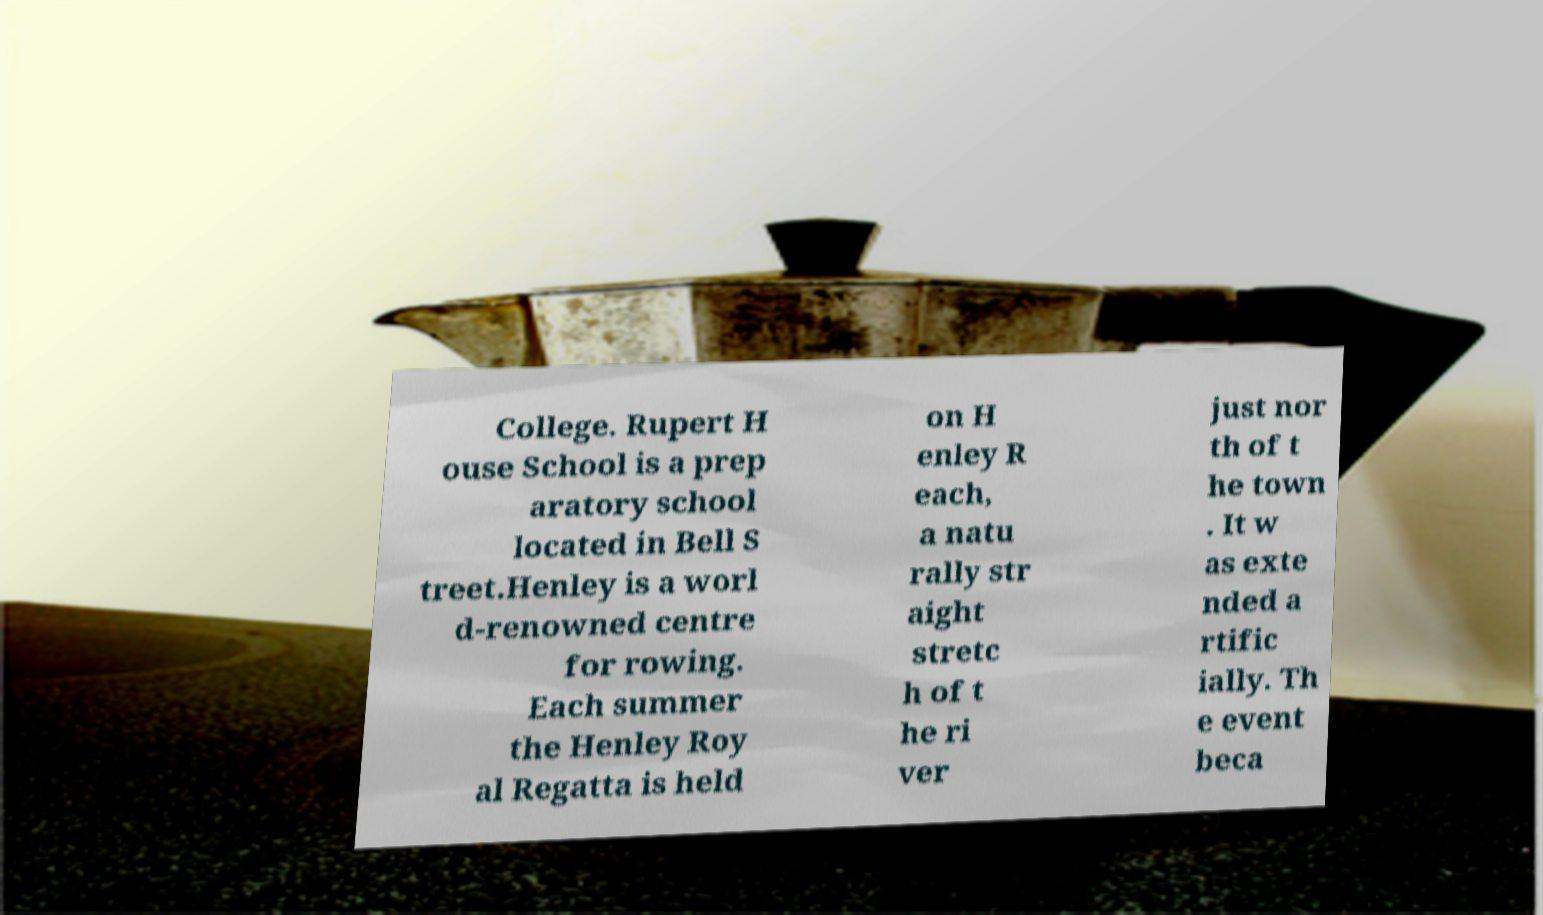Can you accurately transcribe the text from the provided image for me? College. Rupert H ouse School is a prep aratory school located in Bell S treet.Henley is a worl d-renowned centre for rowing. Each summer the Henley Roy al Regatta is held on H enley R each, a natu rally str aight stretc h of t he ri ver just nor th of t he town . It w as exte nded a rtific ially. Th e event beca 